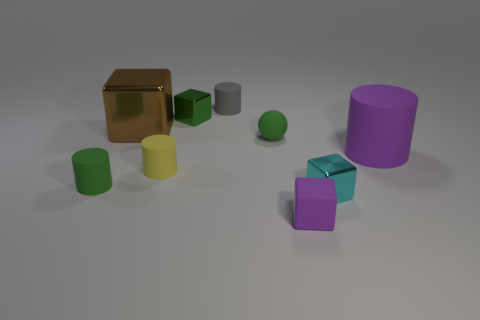There is a rubber thing in front of the green matte cylinder; does it have the same color as the big thing that is in front of the brown thing? The rubber object in question, which appears as a small sphere, does indeed share the same green hue as the larger cylindrical object situated in front of the reflective brown cube. 